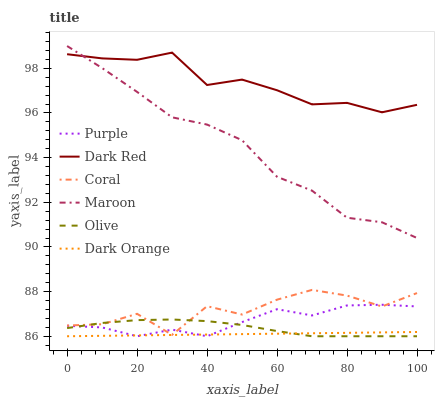Does Dark Orange have the minimum area under the curve?
Answer yes or no. Yes. Does Dark Red have the maximum area under the curve?
Answer yes or no. Yes. Does Purple have the minimum area under the curve?
Answer yes or no. No. Does Purple have the maximum area under the curve?
Answer yes or no. No. Is Dark Orange the smoothest?
Answer yes or no. Yes. Is Coral the roughest?
Answer yes or no. Yes. Is Purple the smoothest?
Answer yes or no. No. Is Purple the roughest?
Answer yes or no. No. Does Dark Orange have the lowest value?
Answer yes or no. Yes. Does Dark Red have the lowest value?
Answer yes or no. No. Does Maroon have the highest value?
Answer yes or no. Yes. Does Purple have the highest value?
Answer yes or no. No. Is Purple less than Maroon?
Answer yes or no. Yes. Is Dark Red greater than Purple?
Answer yes or no. Yes. Does Coral intersect Purple?
Answer yes or no. Yes. Is Coral less than Purple?
Answer yes or no. No. Is Coral greater than Purple?
Answer yes or no. No. Does Purple intersect Maroon?
Answer yes or no. No. 